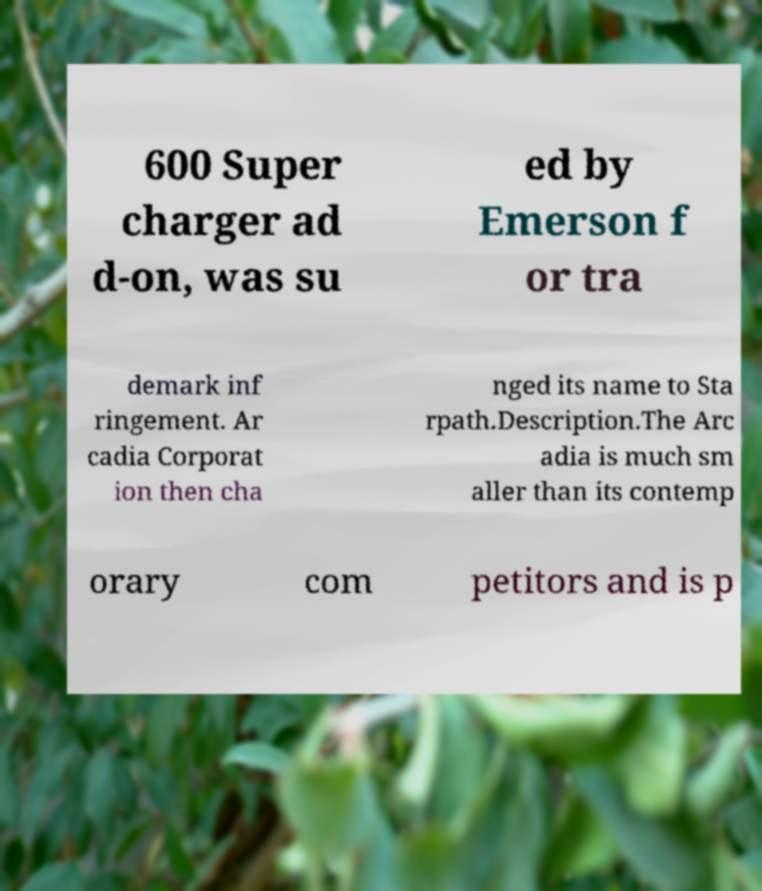Can you read and provide the text displayed in the image?This photo seems to have some interesting text. Can you extract and type it out for me? 600 Super charger ad d-on, was su ed by Emerson f or tra demark inf ringement. Ar cadia Corporat ion then cha nged its name to Sta rpath.Description.The Arc adia is much sm aller than its contemp orary com petitors and is p 